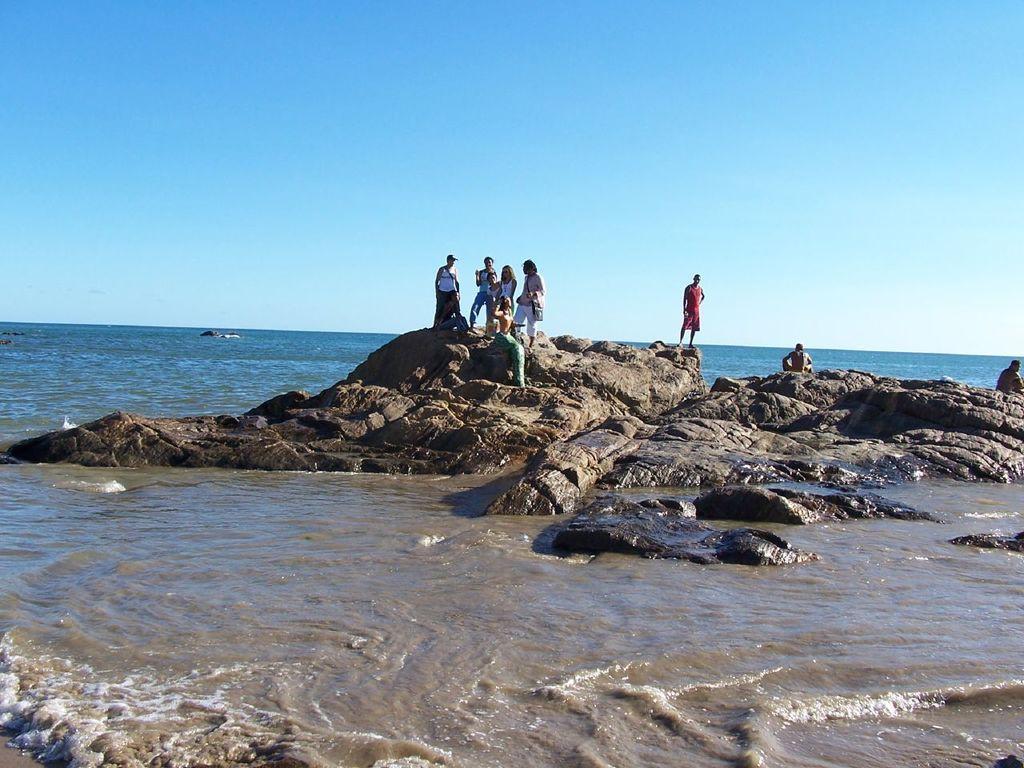Describe this image in one or two sentences. In this image, we can see some water. There are a few people. We can see some rocks. We can see the sky. 